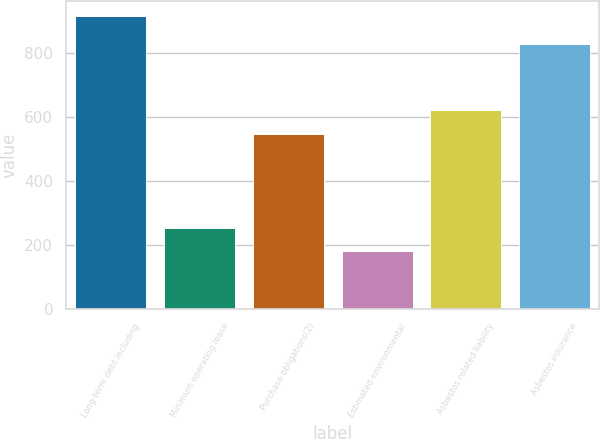<chart> <loc_0><loc_0><loc_500><loc_500><bar_chart><fcel>Long-term debt including<fcel>Minimum operating lease<fcel>Purchase obligations(2)<fcel>Estimated environmental<fcel>Asbestos related liability<fcel>Asbestos insurance<nl><fcel>915<fcel>252.6<fcel>546<fcel>179<fcel>619.6<fcel>826<nl></chart> 